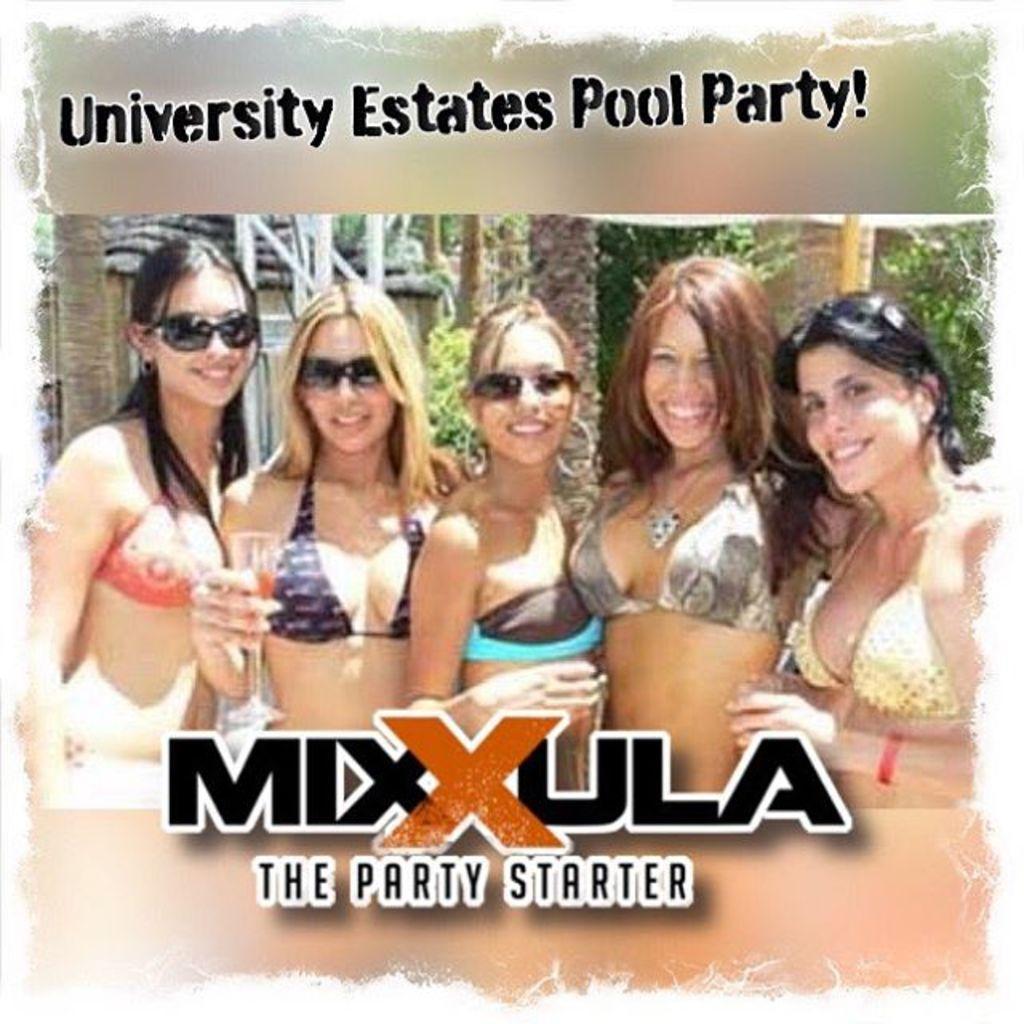In one or two sentences, can you explain what this image depicts? In this image, we can see a poster, on that poster we can see some women and there is some text. 